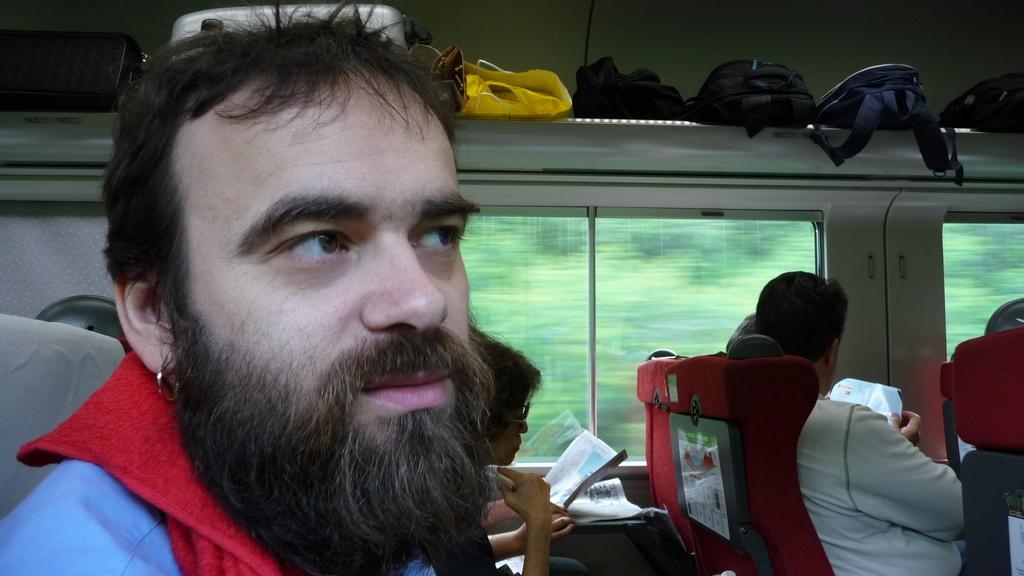Could you give a brief overview of what you see in this image? This picture taken in a vehicle, in this image there are group of people who are sitting and they are holding books and reading. And at the top there are some bags, and in the center there are glass windows through the windows we could see some trees. 